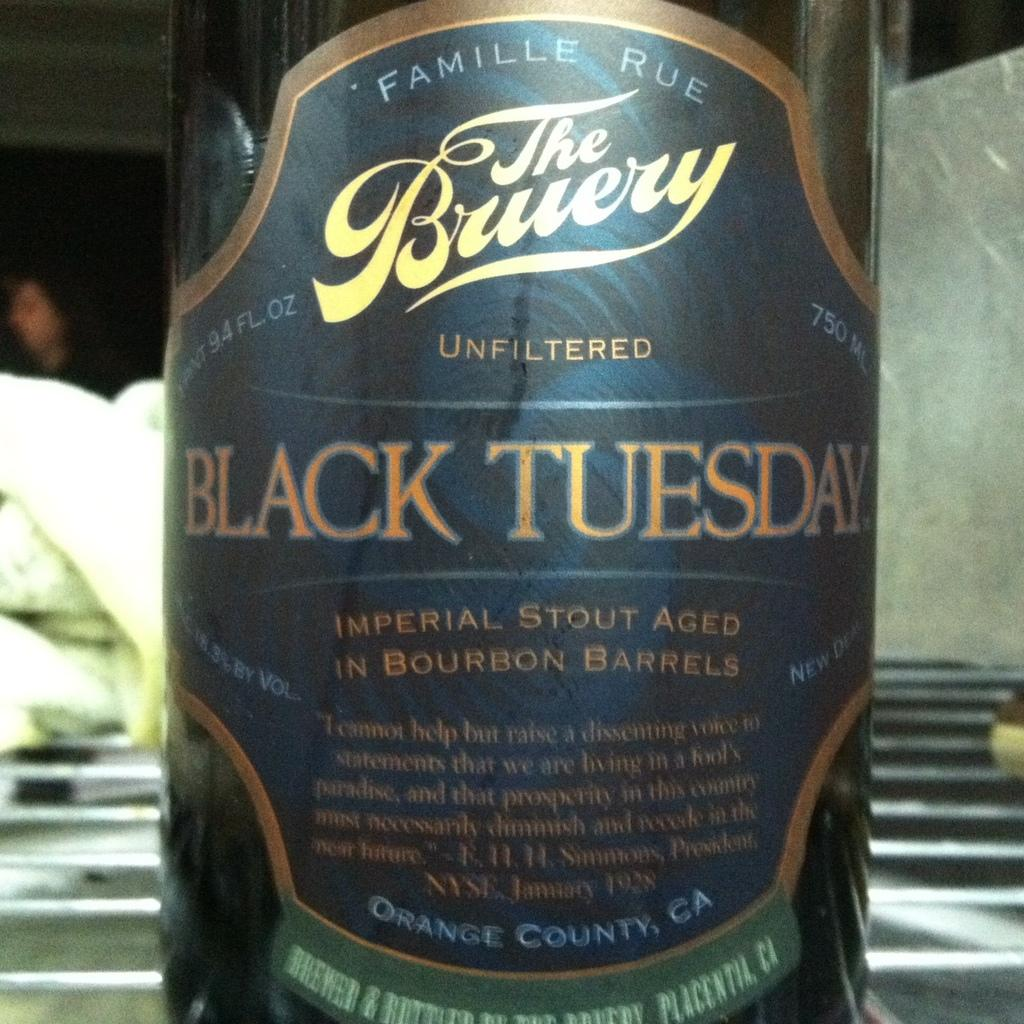Provide a one-sentence caption for the provided image. A bottle of a stout with a label that says Black Tuesday. 